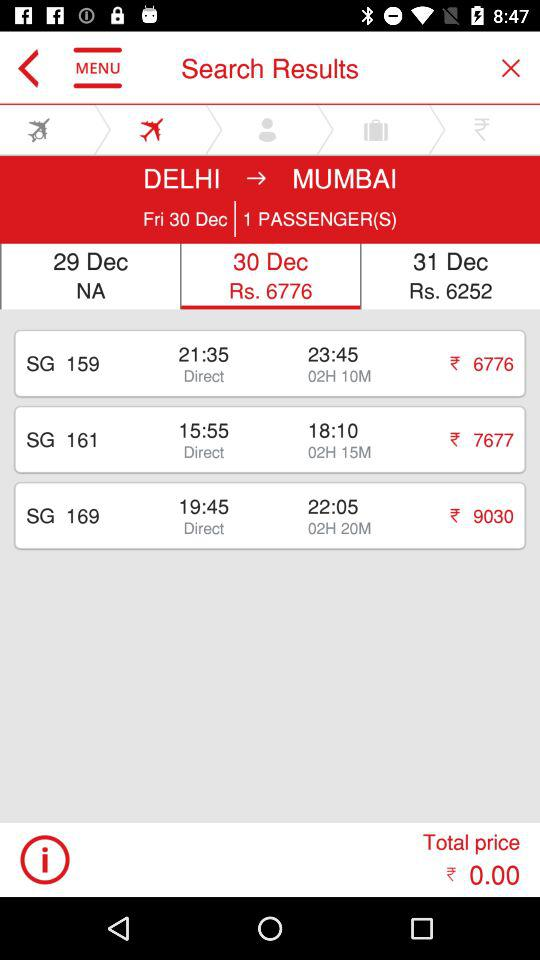What is the fare on 31st December? The fare on December 31st is Rs. 6252. 